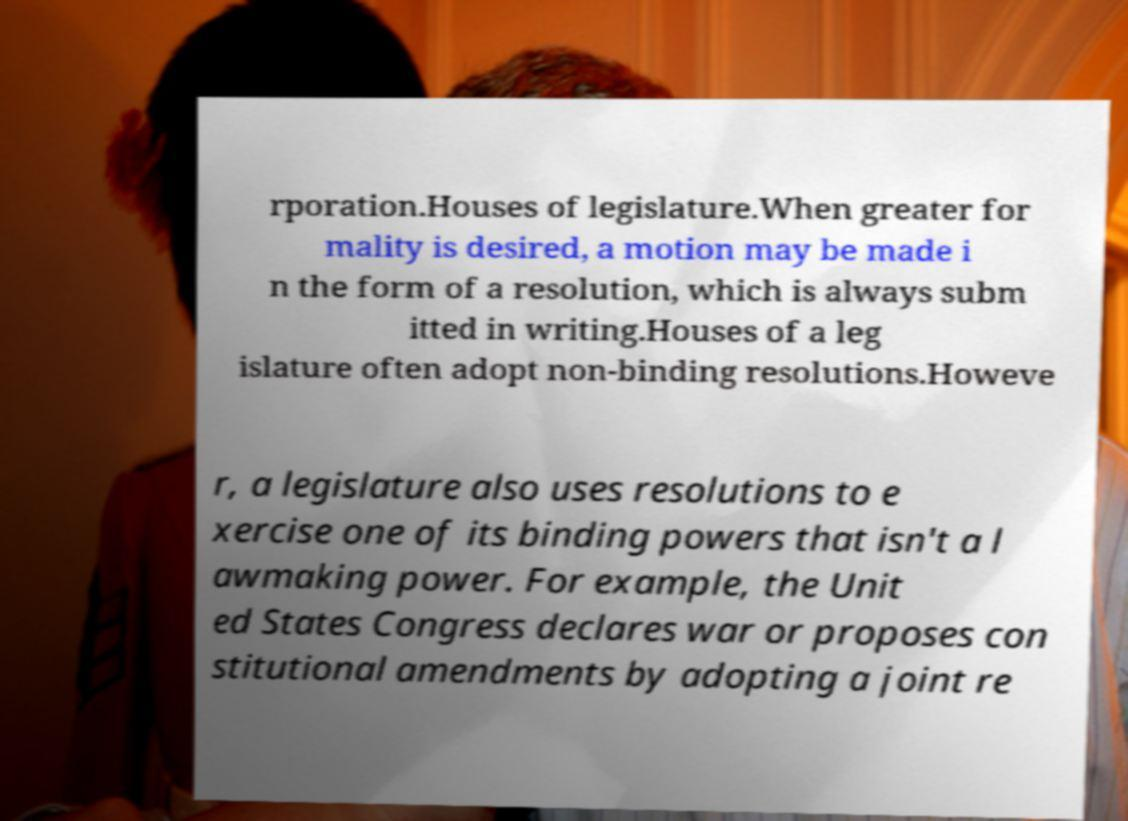Could you extract and type out the text from this image? rporation.Houses of legislature.When greater for mality is desired, a motion may be made i n the form of a resolution, which is always subm itted in writing.Houses of a leg islature often adopt non-binding resolutions.Howeve r, a legislature also uses resolutions to e xercise one of its binding powers that isn't a l awmaking power. For example, the Unit ed States Congress declares war or proposes con stitutional amendments by adopting a joint re 